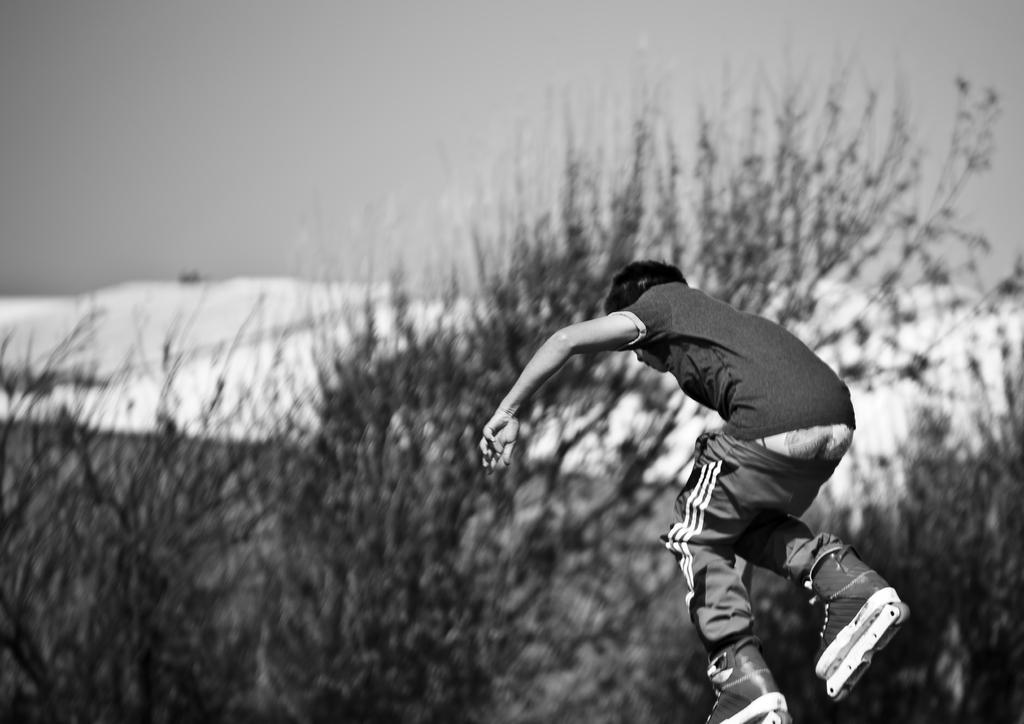Who is the main subject in the image? There is a man in the image. What is the man doing in the image? The man is skating. What type of equipment is the man wearing? The man is wearing skating wheels. What can be seen in the middle of the image? There are trees in the middle of the image. What is the overall setting of the image? The background of the image is covered in snow. What type of apparel is the man wearing to protect himself from the ocean in the image? There is no ocean present in the image, and the man is not wearing any apparel specifically designed for protection from water. 